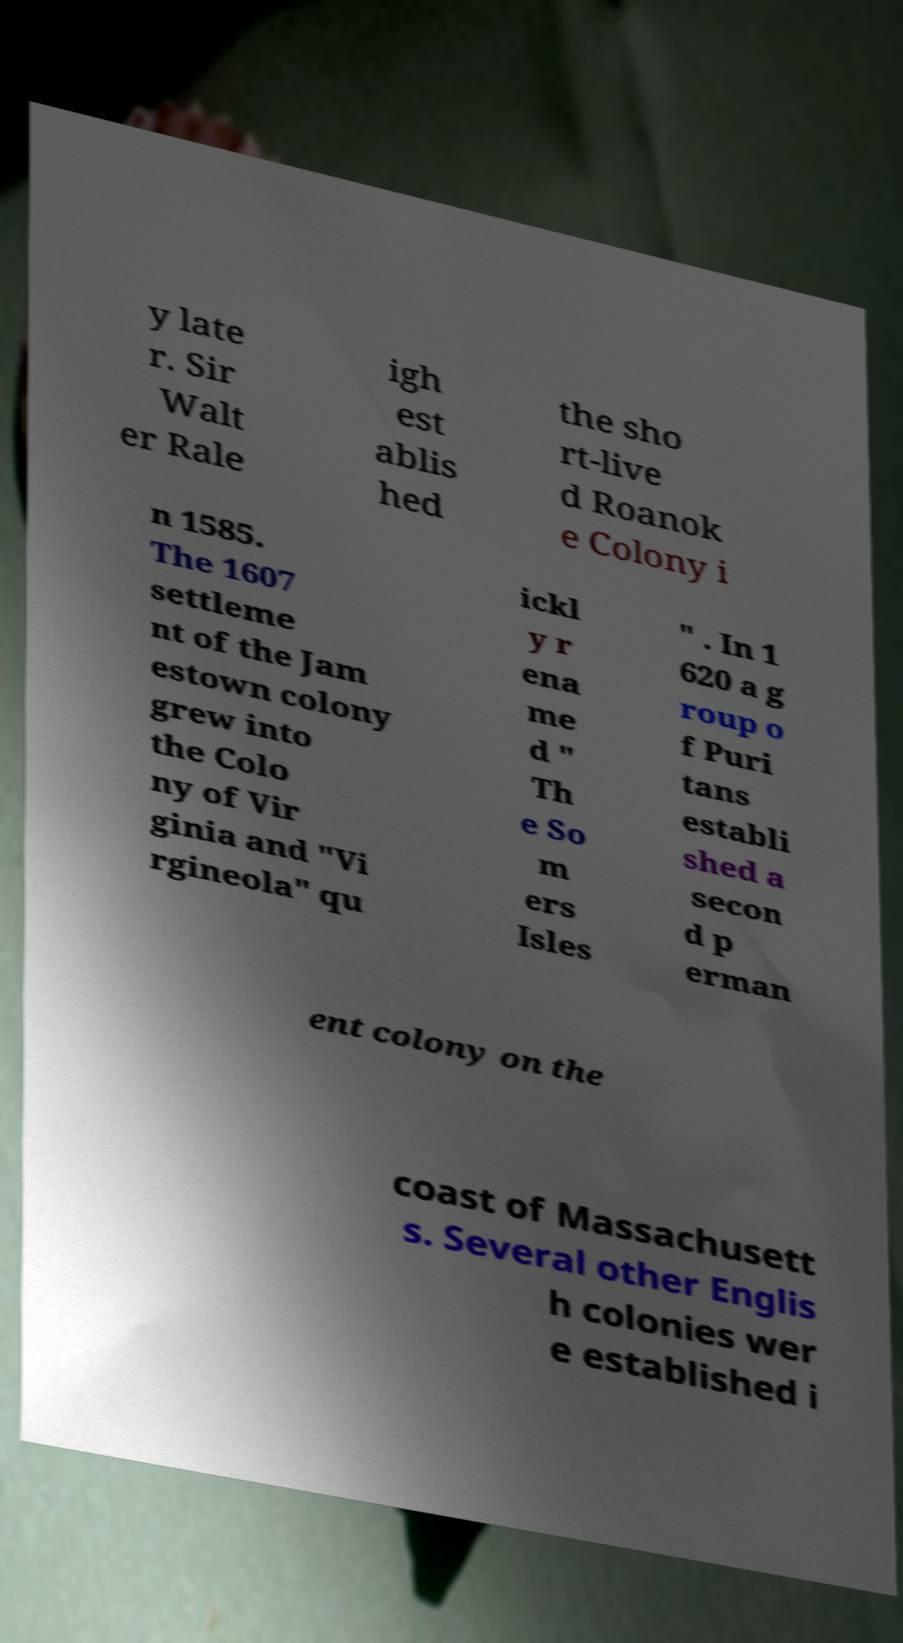Could you assist in decoding the text presented in this image and type it out clearly? y late r. Sir Walt er Rale igh est ablis hed the sho rt-live d Roanok e Colony i n 1585. The 1607 settleme nt of the Jam estown colony grew into the Colo ny of Vir ginia and "Vi rgineola" qu ickl y r ena me d " Th e So m ers Isles " . In 1 620 a g roup o f Puri tans establi shed a secon d p erman ent colony on the coast of Massachusett s. Several other Englis h colonies wer e established i 